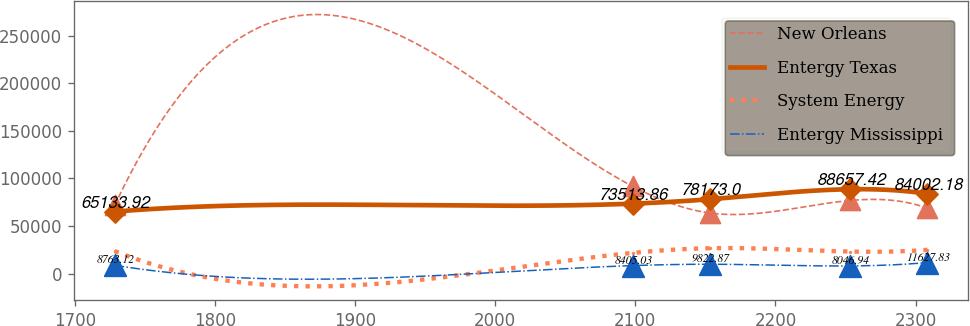Convert chart. <chart><loc_0><loc_0><loc_500><loc_500><line_chart><ecel><fcel>New Orleans<fcel>Entergy Texas<fcel>System Energy<fcel>Entergy Mississippi<nl><fcel>1728.29<fcel>71641.2<fcel>65133.9<fcel>23670.2<fcel>8763.12<nl><fcel>2098.2<fcel>91625.1<fcel>73513.9<fcel>21741.6<fcel>8405.03<nl><fcel>2153.19<fcel>63692<fcel>78173<fcel>26666.9<fcel>9822.87<nl><fcel>2253.42<fcel>76842.3<fcel>88657.4<fcel>23177.6<fcel>8046.94<nl><fcel>2308.41<fcel>68847.9<fcel>84002.2<fcel>24956.1<fcel>11627.8<nl></chart> 